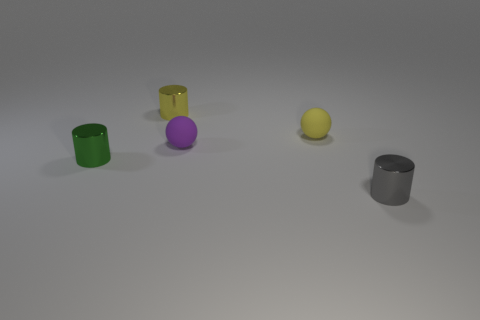What number of cylinders are either small green metallic things or purple matte objects?
Provide a short and direct response. 1. What number of tiny cylinders are both on the left side of the small purple rubber sphere and right of the tiny green metal object?
Make the answer very short. 1. There is a metal cylinder that is on the right side of the purple matte sphere; what is its color?
Your answer should be very brief. Gray. What size is the thing that is made of the same material as the purple sphere?
Keep it short and to the point. Small. There is a small gray object right of the small purple ball; what number of yellow spheres are to the left of it?
Provide a succinct answer. 1. There is a purple thing; how many small objects are right of it?
Offer a terse response. 2. There is a metal cylinder that is left of the metallic thing that is behind the tiny matte sphere left of the yellow sphere; what color is it?
Make the answer very short. Green. Do the metal cylinder that is in front of the green cylinder and the small ball left of the yellow ball have the same color?
Provide a short and direct response. No. There is a metallic object behind the small shiny cylinder that is left of the yellow shiny object; what shape is it?
Offer a very short reply. Cylinder. Is there a purple matte sphere of the same size as the green metallic object?
Make the answer very short. Yes. 